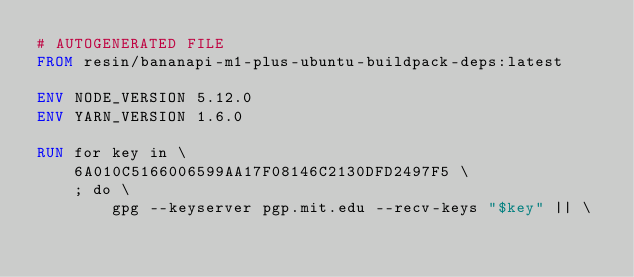Convert code to text. <code><loc_0><loc_0><loc_500><loc_500><_Dockerfile_># AUTOGENERATED FILE
FROM resin/bananapi-m1-plus-ubuntu-buildpack-deps:latest

ENV NODE_VERSION 5.12.0
ENV YARN_VERSION 1.6.0

RUN for key in \
	6A010C5166006599AA17F08146C2130DFD2497F5 \
	; do \
		gpg --keyserver pgp.mit.edu --recv-keys "$key" || \</code> 